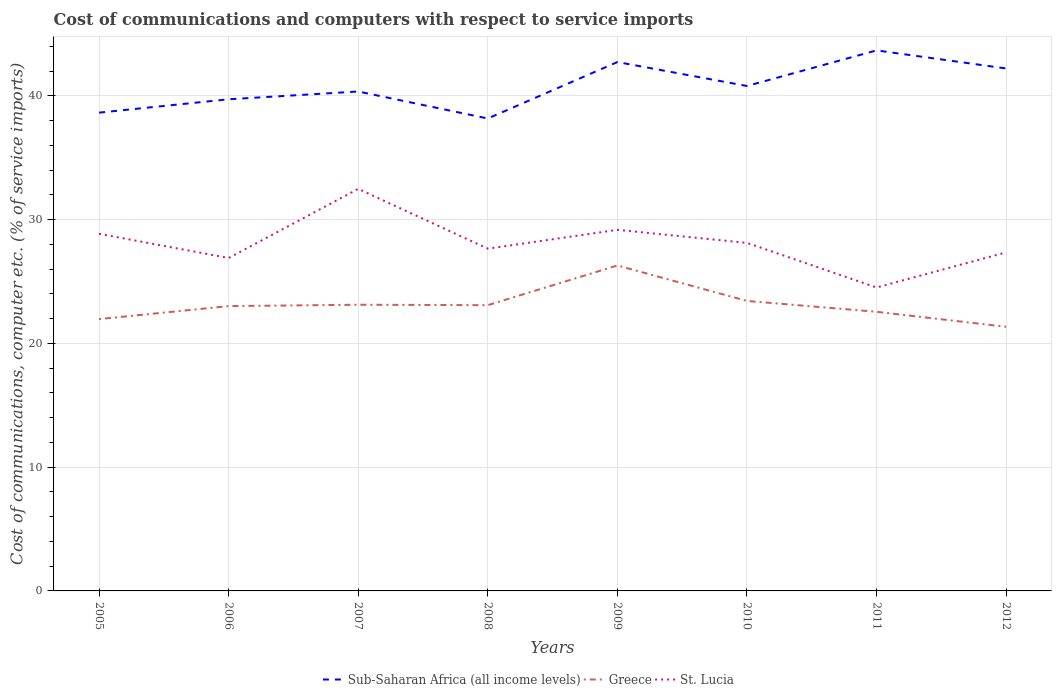Is the number of lines equal to the number of legend labels?
Ensure brevity in your answer.  Yes. Across all years, what is the maximum cost of communications and computers in Sub-Saharan Africa (all income levels)?
Your answer should be very brief. 38.18. In which year was the cost of communications and computers in Greece maximum?
Keep it short and to the point. 2012. What is the total cost of communications and computers in Greece in the graph?
Keep it short and to the point. 1.67. What is the difference between the highest and the second highest cost of communications and computers in St. Lucia?
Offer a very short reply. 7.97. What is the difference between the highest and the lowest cost of communications and computers in Greece?
Make the answer very short. 3. What is the difference between two consecutive major ticks on the Y-axis?
Your answer should be very brief. 10. How are the legend labels stacked?
Your answer should be very brief. Horizontal. What is the title of the graph?
Offer a very short reply. Cost of communications and computers with respect to service imports. Does "Lithuania" appear as one of the legend labels in the graph?
Your answer should be compact. No. What is the label or title of the Y-axis?
Keep it short and to the point. Cost of communications, computer etc. (% of service imports). What is the Cost of communications, computer etc. (% of service imports) in Sub-Saharan Africa (all income levels) in 2005?
Make the answer very short. 38.65. What is the Cost of communications, computer etc. (% of service imports) in Greece in 2005?
Ensure brevity in your answer.  21.97. What is the Cost of communications, computer etc. (% of service imports) of St. Lucia in 2005?
Your answer should be compact. 28.86. What is the Cost of communications, computer etc. (% of service imports) in Sub-Saharan Africa (all income levels) in 2006?
Provide a succinct answer. 39.73. What is the Cost of communications, computer etc. (% of service imports) in Greece in 2006?
Offer a terse response. 23.02. What is the Cost of communications, computer etc. (% of service imports) of St. Lucia in 2006?
Keep it short and to the point. 26.91. What is the Cost of communications, computer etc. (% of service imports) in Sub-Saharan Africa (all income levels) in 2007?
Make the answer very short. 40.36. What is the Cost of communications, computer etc. (% of service imports) in Greece in 2007?
Provide a short and direct response. 23.13. What is the Cost of communications, computer etc. (% of service imports) of St. Lucia in 2007?
Your answer should be compact. 32.49. What is the Cost of communications, computer etc. (% of service imports) of Sub-Saharan Africa (all income levels) in 2008?
Your answer should be compact. 38.18. What is the Cost of communications, computer etc. (% of service imports) in Greece in 2008?
Provide a short and direct response. 23.09. What is the Cost of communications, computer etc. (% of service imports) in St. Lucia in 2008?
Ensure brevity in your answer.  27.66. What is the Cost of communications, computer etc. (% of service imports) of Sub-Saharan Africa (all income levels) in 2009?
Ensure brevity in your answer.  42.74. What is the Cost of communications, computer etc. (% of service imports) of Greece in 2009?
Your response must be concise. 26.3. What is the Cost of communications, computer etc. (% of service imports) in St. Lucia in 2009?
Offer a very short reply. 29.18. What is the Cost of communications, computer etc. (% of service imports) of Sub-Saharan Africa (all income levels) in 2010?
Your answer should be compact. 40.81. What is the Cost of communications, computer etc. (% of service imports) of Greece in 2010?
Offer a terse response. 23.44. What is the Cost of communications, computer etc. (% of service imports) in St. Lucia in 2010?
Your answer should be compact. 28.13. What is the Cost of communications, computer etc. (% of service imports) of Sub-Saharan Africa (all income levels) in 2011?
Offer a terse response. 43.68. What is the Cost of communications, computer etc. (% of service imports) in Greece in 2011?
Offer a very short reply. 22.56. What is the Cost of communications, computer etc. (% of service imports) in St. Lucia in 2011?
Ensure brevity in your answer.  24.52. What is the Cost of communications, computer etc. (% of service imports) of Sub-Saharan Africa (all income levels) in 2012?
Make the answer very short. 42.22. What is the Cost of communications, computer etc. (% of service imports) in Greece in 2012?
Keep it short and to the point. 21.35. What is the Cost of communications, computer etc. (% of service imports) of St. Lucia in 2012?
Keep it short and to the point. 27.36. Across all years, what is the maximum Cost of communications, computer etc. (% of service imports) of Sub-Saharan Africa (all income levels)?
Your response must be concise. 43.68. Across all years, what is the maximum Cost of communications, computer etc. (% of service imports) in Greece?
Offer a terse response. 26.3. Across all years, what is the maximum Cost of communications, computer etc. (% of service imports) in St. Lucia?
Make the answer very short. 32.49. Across all years, what is the minimum Cost of communications, computer etc. (% of service imports) in Sub-Saharan Africa (all income levels)?
Make the answer very short. 38.18. Across all years, what is the minimum Cost of communications, computer etc. (% of service imports) of Greece?
Make the answer very short. 21.35. Across all years, what is the minimum Cost of communications, computer etc. (% of service imports) in St. Lucia?
Offer a terse response. 24.52. What is the total Cost of communications, computer etc. (% of service imports) in Sub-Saharan Africa (all income levels) in the graph?
Provide a succinct answer. 326.39. What is the total Cost of communications, computer etc. (% of service imports) in Greece in the graph?
Your answer should be compact. 184.85. What is the total Cost of communications, computer etc. (% of service imports) of St. Lucia in the graph?
Offer a terse response. 225.11. What is the difference between the Cost of communications, computer etc. (% of service imports) of Sub-Saharan Africa (all income levels) in 2005 and that in 2006?
Your answer should be compact. -1.08. What is the difference between the Cost of communications, computer etc. (% of service imports) in Greece in 2005 and that in 2006?
Provide a succinct answer. -1.05. What is the difference between the Cost of communications, computer etc. (% of service imports) in St. Lucia in 2005 and that in 2006?
Your response must be concise. 1.96. What is the difference between the Cost of communications, computer etc. (% of service imports) in Sub-Saharan Africa (all income levels) in 2005 and that in 2007?
Offer a terse response. -1.71. What is the difference between the Cost of communications, computer etc. (% of service imports) of Greece in 2005 and that in 2007?
Offer a very short reply. -1.16. What is the difference between the Cost of communications, computer etc. (% of service imports) in St. Lucia in 2005 and that in 2007?
Give a very brief answer. -3.63. What is the difference between the Cost of communications, computer etc. (% of service imports) of Sub-Saharan Africa (all income levels) in 2005 and that in 2008?
Keep it short and to the point. 0.47. What is the difference between the Cost of communications, computer etc. (% of service imports) in Greece in 2005 and that in 2008?
Keep it short and to the point. -1.13. What is the difference between the Cost of communications, computer etc. (% of service imports) in St. Lucia in 2005 and that in 2008?
Provide a short and direct response. 1.21. What is the difference between the Cost of communications, computer etc. (% of service imports) in Sub-Saharan Africa (all income levels) in 2005 and that in 2009?
Your answer should be very brief. -4.09. What is the difference between the Cost of communications, computer etc. (% of service imports) of Greece in 2005 and that in 2009?
Offer a very short reply. -4.33. What is the difference between the Cost of communications, computer etc. (% of service imports) of St. Lucia in 2005 and that in 2009?
Keep it short and to the point. -0.32. What is the difference between the Cost of communications, computer etc. (% of service imports) in Sub-Saharan Africa (all income levels) in 2005 and that in 2010?
Your answer should be very brief. -2.15. What is the difference between the Cost of communications, computer etc. (% of service imports) in Greece in 2005 and that in 2010?
Your answer should be compact. -1.47. What is the difference between the Cost of communications, computer etc. (% of service imports) of St. Lucia in 2005 and that in 2010?
Offer a very short reply. 0.74. What is the difference between the Cost of communications, computer etc. (% of service imports) of Sub-Saharan Africa (all income levels) in 2005 and that in 2011?
Ensure brevity in your answer.  -5.03. What is the difference between the Cost of communications, computer etc. (% of service imports) of Greece in 2005 and that in 2011?
Your response must be concise. -0.59. What is the difference between the Cost of communications, computer etc. (% of service imports) in St. Lucia in 2005 and that in 2011?
Make the answer very short. 4.34. What is the difference between the Cost of communications, computer etc. (% of service imports) in Sub-Saharan Africa (all income levels) in 2005 and that in 2012?
Make the answer very short. -3.57. What is the difference between the Cost of communications, computer etc. (% of service imports) of Greece in 2005 and that in 2012?
Provide a short and direct response. 0.62. What is the difference between the Cost of communications, computer etc. (% of service imports) of St. Lucia in 2005 and that in 2012?
Provide a succinct answer. 1.5. What is the difference between the Cost of communications, computer etc. (% of service imports) in Sub-Saharan Africa (all income levels) in 2006 and that in 2007?
Give a very brief answer. -0.63. What is the difference between the Cost of communications, computer etc. (% of service imports) of Greece in 2006 and that in 2007?
Provide a short and direct response. -0.11. What is the difference between the Cost of communications, computer etc. (% of service imports) of St. Lucia in 2006 and that in 2007?
Your answer should be compact. -5.59. What is the difference between the Cost of communications, computer etc. (% of service imports) in Sub-Saharan Africa (all income levels) in 2006 and that in 2008?
Keep it short and to the point. 1.55. What is the difference between the Cost of communications, computer etc. (% of service imports) of Greece in 2006 and that in 2008?
Your response must be concise. -0.08. What is the difference between the Cost of communications, computer etc. (% of service imports) in St. Lucia in 2006 and that in 2008?
Provide a succinct answer. -0.75. What is the difference between the Cost of communications, computer etc. (% of service imports) in Sub-Saharan Africa (all income levels) in 2006 and that in 2009?
Offer a terse response. -3.01. What is the difference between the Cost of communications, computer etc. (% of service imports) of Greece in 2006 and that in 2009?
Give a very brief answer. -3.28. What is the difference between the Cost of communications, computer etc. (% of service imports) in St. Lucia in 2006 and that in 2009?
Make the answer very short. -2.28. What is the difference between the Cost of communications, computer etc. (% of service imports) in Sub-Saharan Africa (all income levels) in 2006 and that in 2010?
Your answer should be compact. -1.07. What is the difference between the Cost of communications, computer etc. (% of service imports) in Greece in 2006 and that in 2010?
Provide a succinct answer. -0.42. What is the difference between the Cost of communications, computer etc. (% of service imports) in St. Lucia in 2006 and that in 2010?
Offer a terse response. -1.22. What is the difference between the Cost of communications, computer etc. (% of service imports) in Sub-Saharan Africa (all income levels) in 2006 and that in 2011?
Your response must be concise. -3.95. What is the difference between the Cost of communications, computer etc. (% of service imports) of Greece in 2006 and that in 2011?
Ensure brevity in your answer.  0.46. What is the difference between the Cost of communications, computer etc. (% of service imports) in St. Lucia in 2006 and that in 2011?
Make the answer very short. 2.38. What is the difference between the Cost of communications, computer etc. (% of service imports) in Sub-Saharan Africa (all income levels) in 2006 and that in 2012?
Provide a succinct answer. -2.49. What is the difference between the Cost of communications, computer etc. (% of service imports) of Greece in 2006 and that in 2012?
Your response must be concise. 1.67. What is the difference between the Cost of communications, computer etc. (% of service imports) of St. Lucia in 2006 and that in 2012?
Your response must be concise. -0.45. What is the difference between the Cost of communications, computer etc. (% of service imports) of Sub-Saharan Africa (all income levels) in 2007 and that in 2008?
Give a very brief answer. 2.18. What is the difference between the Cost of communications, computer etc. (% of service imports) of Greece in 2007 and that in 2008?
Your response must be concise. 0.04. What is the difference between the Cost of communications, computer etc. (% of service imports) of St. Lucia in 2007 and that in 2008?
Offer a terse response. 4.83. What is the difference between the Cost of communications, computer etc. (% of service imports) of Sub-Saharan Africa (all income levels) in 2007 and that in 2009?
Offer a terse response. -2.38. What is the difference between the Cost of communications, computer etc. (% of service imports) of Greece in 2007 and that in 2009?
Offer a very short reply. -3.17. What is the difference between the Cost of communications, computer etc. (% of service imports) of St. Lucia in 2007 and that in 2009?
Offer a terse response. 3.31. What is the difference between the Cost of communications, computer etc. (% of service imports) of Sub-Saharan Africa (all income levels) in 2007 and that in 2010?
Offer a terse response. -0.45. What is the difference between the Cost of communications, computer etc. (% of service imports) of Greece in 2007 and that in 2010?
Provide a short and direct response. -0.31. What is the difference between the Cost of communications, computer etc. (% of service imports) of St. Lucia in 2007 and that in 2010?
Make the answer very short. 4.36. What is the difference between the Cost of communications, computer etc. (% of service imports) in Sub-Saharan Africa (all income levels) in 2007 and that in 2011?
Your answer should be very brief. -3.32. What is the difference between the Cost of communications, computer etc. (% of service imports) in Greece in 2007 and that in 2011?
Your answer should be compact. 0.57. What is the difference between the Cost of communications, computer etc. (% of service imports) of St. Lucia in 2007 and that in 2011?
Provide a short and direct response. 7.97. What is the difference between the Cost of communications, computer etc. (% of service imports) of Sub-Saharan Africa (all income levels) in 2007 and that in 2012?
Keep it short and to the point. -1.86. What is the difference between the Cost of communications, computer etc. (% of service imports) of Greece in 2007 and that in 2012?
Your answer should be compact. 1.78. What is the difference between the Cost of communications, computer etc. (% of service imports) in St. Lucia in 2007 and that in 2012?
Make the answer very short. 5.13. What is the difference between the Cost of communications, computer etc. (% of service imports) in Sub-Saharan Africa (all income levels) in 2008 and that in 2009?
Offer a very short reply. -4.56. What is the difference between the Cost of communications, computer etc. (% of service imports) of Greece in 2008 and that in 2009?
Make the answer very short. -3.21. What is the difference between the Cost of communications, computer etc. (% of service imports) in St. Lucia in 2008 and that in 2009?
Your response must be concise. -1.52. What is the difference between the Cost of communications, computer etc. (% of service imports) of Sub-Saharan Africa (all income levels) in 2008 and that in 2010?
Offer a very short reply. -2.63. What is the difference between the Cost of communications, computer etc. (% of service imports) in Greece in 2008 and that in 2010?
Your answer should be compact. -0.34. What is the difference between the Cost of communications, computer etc. (% of service imports) of St. Lucia in 2008 and that in 2010?
Give a very brief answer. -0.47. What is the difference between the Cost of communications, computer etc. (% of service imports) in Sub-Saharan Africa (all income levels) in 2008 and that in 2011?
Ensure brevity in your answer.  -5.5. What is the difference between the Cost of communications, computer etc. (% of service imports) of Greece in 2008 and that in 2011?
Make the answer very short. 0.53. What is the difference between the Cost of communications, computer etc. (% of service imports) of St. Lucia in 2008 and that in 2011?
Your response must be concise. 3.14. What is the difference between the Cost of communications, computer etc. (% of service imports) of Sub-Saharan Africa (all income levels) in 2008 and that in 2012?
Offer a very short reply. -4.04. What is the difference between the Cost of communications, computer etc. (% of service imports) in Greece in 2008 and that in 2012?
Provide a succinct answer. 1.75. What is the difference between the Cost of communications, computer etc. (% of service imports) in St. Lucia in 2008 and that in 2012?
Your answer should be compact. 0.3. What is the difference between the Cost of communications, computer etc. (% of service imports) in Sub-Saharan Africa (all income levels) in 2009 and that in 2010?
Provide a short and direct response. 1.93. What is the difference between the Cost of communications, computer etc. (% of service imports) in Greece in 2009 and that in 2010?
Make the answer very short. 2.87. What is the difference between the Cost of communications, computer etc. (% of service imports) in St. Lucia in 2009 and that in 2010?
Give a very brief answer. 1.06. What is the difference between the Cost of communications, computer etc. (% of service imports) of Sub-Saharan Africa (all income levels) in 2009 and that in 2011?
Offer a terse response. -0.94. What is the difference between the Cost of communications, computer etc. (% of service imports) of Greece in 2009 and that in 2011?
Offer a terse response. 3.74. What is the difference between the Cost of communications, computer etc. (% of service imports) in St. Lucia in 2009 and that in 2011?
Keep it short and to the point. 4.66. What is the difference between the Cost of communications, computer etc. (% of service imports) of Sub-Saharan Africa (all income levels) in 2009 and that in 2012?
Make the answer very short. 0.52. What is the difference between the Cost of communications, computer etc. (% of service imports) in Greece in 2009 and that in 2012?
Provide a succinct answer. 4.96. What is the difference between the Cost of communications, computer etc. (% of service imports) of St. Lucia in 2009 and that in 2012?
Offer a terse response. 1.82. What is the difference between the Cost of communications, computer etc. (% of service imports) of Sub-Saharan Africa (all income levels) in 2010 and that in 2011?
Give a very brief answer. -2.88. What is the difference between the Cost of communications, computer etc. (% of service imports) in Greece in 2010 and that in 2011?
Keep it short and to the point. 0.88. What is the difference between the Cost of communications, computer etc. (% of service imports) of St. Lucia in 2010 and that in 2011?
Ensure brevity in your answer.  3.6. What is the difference between the Cost of communications, computer etc. (% of service imports) of Sub-Saharan Africa (all income levels) in 2010 and that in 2012?
Provide a short and direct response. -1.42. What is the difference between the Cost of communications, computer etc. (% of service imports) in Greece in 2010 and that in 2012?
Provide a short and direct response. 2.09. What is the difference between the Cost of communications, computer etc. (% of service imports) in St. Lucia in 2010 and that in 2012?
Ensure brevity in your answer.  0.77. What is the difference between the Cost of communications, computer etc. (% of service imports) of Sub-Saharan Africa (all income levels) in 2011 and that in 2012?
Make the answer very short. 1.46. What is the difference between the Cost of communications, computer etc. (% of service imports) of Greece in 2011 and that in 2012?
Ensure brevity in your answer.  1.21. What is the difference between the Cost of communications, computer etc. (% of service imports) in St. Lucia in 2011 and that in 2012?
Your response must be concise. -2.84. What is the difference between the Cost of communications, computer etc. (% of service imports) of Sub-Saharan Africa (all income levels) in 2005 and the Cost of communications, computer etc. (% of service imports) of Greece in 2006?
Your answer should be compact. 15.64. What is the difference between the Cost of communications, computer etc. (% of service imports) in Sub-Saharan Africa (all income levels) in 2005 and the Cost of communications, computer etc. (% of service imports) in St. Lucia in 2006?
Provide a succinct answer. 11.75. What is the difference between the Cost of communications, computer etc. (% of service imports) of Greece in 2005 and the Cost of communications, computer etc. (% of service imports) of St. Lucia in 2006?
Keep it short and to the point. -4.94. What is the difference between the Cost of communications, computer etc. (% of service imports) in Sub-Saharan Africa (all income levels) in 2005 and the Cost of communications, computer etc. (% of service imports) in Greece in 2007?
Your response must be concise. 15.52. What is the difference between the Cost of communications, computer etc. (% of service imports) in Sub-Saharan Africa (all income levels) in 2005 and the Cost of communications, computer etc. (% of service imports) in St. Lucia in 2007?
Your answer should be compact. 6.16. What is the difference between the Cost of communications, computer etc. (% of service imports) of Greece in 2005 and the Cost of communications, computer etc. (% of service imports) of St. Lucia in 2007?
Offer a terse response. -10.52. What is the difference between the Cost of communications, computer etc. (% of service imports) of Sub-Saharan Africa (all income levels) in 2005 and the Cost of communications, computer etc. (% of service imports) of Greece in 2008?
Offer a terse response. 15.56. What is the difference between the Cost of communications, computer etc. (% of service imports) of Sub-Saharan Africa (all income levels) in 2005 and the Cost of communications, computer etc. (% of service imports) of St. Lucia in 2008?
Make the answer very short. 11. What is the difference between the Cost of communications, computer etc. (% of service imports) of Greece in 2005 and the Cost of communications, computer etc. (% of service imports) of St. Lucia in 2008?
Your answer should be very brief. -5.69. What is the difference between the Cost of communications, computer etc. (% of service imports) of Sub-Saharan Africa (all income levels) in 2005 and the Cost of communications, computer etc. (% of service imports) of Greece in 2009?
Offer a terse response. 12.35. What is the difference between the Cost of communications, computer etc. (% of service imports) in Sub-Saharan Africa (all income levels) in 2005 and the Cost of communications, computer etc. (% of service imports) in St. Lucia in 2009?
Offer a terse response. 9.47. What is the difference between the Cost of communications, computer etc. (% of service imports) of Greece in 2005 and the Cost of communications, computer etc. (% of service imports) of St. Lucia in 2009?
Provide a short and direct response. -7.21. What is the difference between the Cost of communications, computer etc. (% of service imports) in Sub-Saharan Africa (all income levels) in 2005 and the Cost of communications, computer etc. (% of service imports) in Greece in 2010?
Provide a succinct answer. 15.22. What is the difference between the Cost of communications, computer etc. (% of service imports) in Sub-Saharan Africa (all income levels) in 2005 and the Cost of communications, computer etc. (% of service imports) in St. Lucia in 2010?
Ensure brevity in your answer.  10.53. What is the difference between the Cost of communications, computer etc. (% of service imports) of Greece in 2005 and the Cost of communications, computer etc. (% of service imports) of St. Lucia in 2010?
Provide a succinct answer. -6.16. What is the difference between the Cost of communications, computer etc. (% of service imports) in Sub-Saharan Africa (all income levels) in 2005 and the Cost of communications, computer etc. (% of service imports) in Greece in 2011?
Provide a succinct answer. 16.1. What is the difference between the Cost of communications, computer etc. (% of service imports) of Sub-Saharan Africa (all income levels) in 2005 and the Cost of communications, computer etc. (% of service imports) of St. Lucia in 2011?
Keep it short and to the point. 14.13. What is the difference between the Cost of communications, computer etc. (% of service imports) of Greece in 2005 and the Cost of communications, computer etc. (% of service imports) of St. Lucia in 2011?
Your answer should be very brief. -2.55. What is the difference between the Cost of communications, computer etc. (% of service imports) in Sub-Saharan Africa (all income levels) in 2005 and the Cost of communications, computer etc. (% of service imports) in Greece in 2012?
Ensure brevity in your answer.  17.31. What is the difference between the Cost of communications, computer etc. (% of service imports) of Sub-Saharan Africa (all income levels) in 2005 and the Cost of communications, computer etc. (% of service imports) of St. Lucia in 2012?
Make the answer very short. 11.29. What is the difference between the Cost of communications, computer etc. (% of service imports) in Greece in 2005 and the Cost of communications, computer etc. (% of service imports) in St. Lucia in 2012?
Your answer should be compact. -5.39. What is the difference between the Cost of communications, computer etc. (% of service imports) in Sub-Saharan Africa (all income levels) in 2006 and the Cost of communications, computer etc. (% of service imports) in Greece in 2007?
Make the answer very short. 16.61. What is the difference between the Cost of communications, computer etc. (% of service imports) in Sub-Saharan Africa (all income levels) in 2006 and the Cost of communications, computer etc. (% of service imports) in St. Lucia in 2007?
Provide a succinct answer. 7.24. What is the difference between the Cost of communications, computer etc. (% of service imports) of Greece in 2006 and the Cost of communications, computer etc. (% of service imports) of St. Lucia in 2007?
Offer a terse response. -9.47. What is the difference between the Cost of communications, computer etc. (% of service imports) of Sub-Saharan Africa (all income levels) in 2006 and the Cost of communications, computer etc. (% of service imports) of Greece in 2008?
Offer a terse response. 16.64. What is the difference between the Cost of communications, computer etc. (% of service imports) in Sub-Saharan Africa (all income levels) in 2006 and the Cost of communications, computer etc. (% of service imports) in St. Lucia in 2008?
Ensure brevity in your answer.  12.08. What is the difference between the Cost of communications, computer etc. (% of service imports) in Greece in 2006 and the Cost of communications, computer etc. (% of service imports) in St. Lucia in 2008?
Make the answer very short. -4.64. What is the difference between the Cost of communications, computer etc. (% of service imports) of Sub-Saharan Africa (all income levels) in 2006 and the Cost of communications, computer etc. (% of service imports) of Greece in 2009?
Your answer should be very brief. 13.43. What is the difference between the Cost of communications, computer etc. (% of service imports) in Sub-Saharan Africa (all income levels) in 2006 and the Cost of communications, computer etc. (% of service imports) in St. Lucia in 2009?
Make the answer very short. 10.55. What is the difference between the Cost of communications, computer etc. (% of service imports) in Greece in 2006 and the Cost of communications, computer etc. (% of service imports) in St. Lucia in 2009?
Your response must be concise. -6.16. What is the difference between the Cost of communications, computer etc. (% of service imports) in Sub-Saharan Africa (all income levels) in 2006 and the Cost of communications, computer etc. (% of service imports) in Greece in 2010?
Offer a terse response. 16.3. What is the difference between the Cost of communications, computer etc. (% of service imports) of Sub-Saharan Africa (all income levels) in 2006 and the Cost of communications, computer etc. (% of service imports) of St. Lucia in 2010?
Ensure brevity in your answer.  11.61. What is the difference between the Cost of communications, computer etc. (% of service imports) of Greece in 2006 and the Cost of communications, computer etc. (% of service imports) of St. Lucia in 2010?
Your answer should be compact. -5.11. What is the difference between the Cost of communications, computer etc. (% of service imports) of Sub-Saharan Africa (all income levels) in 2006 and the Cost of communications, computer etc. (% of service imports) of Greece in 2011?
Your answer should be very brief. 17.18. What is the difference between the Cost of communications, computer etc. (% of service imports) of Sub-Saharan Africa (all income levels) in 2006 and the Cost of communications, computer etc. (% of service imports) of St. Lucia in 2011?
Make the answer very short. 15.21. What is the difference between the Cost of communications, computer etc. (% of service imports) of Greece in 2006 and the Cost of communications, computer etc. (% of service imports) of St. Lucia in 2011?
Give a very brief answer. -1.5. What is the difference between the Cost of communications, computer etc. (% of service imports) in Sub-Saharan Africa (all income levels) in 2006 and the Cost of communications, computer etc. (% of service imports) in Greece in 2012?
Offer a very short reply. 18.39. What is the difference between the Cost of communications, computer etc. (% of service imports) in Sub-Saharan Africa (all income levels) in 2006 and the Cost of communications, computer etc. (% of service imports) in St. Lucia in 2012?
Offer a very short reply. 12.37. What is the difference between the Cost of communications, computer etc. (% of service imports) of Greece in 2006 and the Cost of communications, computer etc. (% of service imports) of St. Lucia in 2012?
Provide a short and direct response. -4.34. What is the difference between the Cost of communications, computer etc. (% of service imports) of Sub-Saharan Africa (all income levels) in 2007 and the Cost of communications, computer etc. (% of service imports) of Greece in 2008?
Ensure brevity in your answer.  17.27. What is the difference between the Cost of communications, computer etc. (% of service imports) of Sub-Saharan Africa (all income levels) in 2007 and the Cost of communications, computer etc. (% of service imports) of St. Lucia in 2008?
Offer a very short reply. 12.7. What is the difference between the Cost of communications, computer etc. (% of service imports) in Greece in 2007 and the Cost of communications, computer etc. (% of service imports) in St. Lucia in 2008?
Offer a terse response. -4.53. What is the difference between the Cost of communications, computer etc. (% of service imports) of Sub-Saharan Africa (all income levels) in 2007 and the Cost of communications, computer etc. (% of service imports) of Greece in 2009?
Your answer should be very brief. 14.06. What is the difference between the Cost of communications, computer etc. (% of service imports) of Sub-Saharan Africa (all income levels) in 2007 and the Cost of communications, computer etc. (% of service imports) of St. Lucia in 2009?
Make the answer very short. 11.18. What is the difference between the Cost of communications, computer etc. (% of service imports) in Greece in 2007 and the Cost of communications, computer etc. (% of service imports) in St. Lucia in 2009?
Your answer should be very brief. -6.05. What is the difference between the Cost of communications, computer etc. (% of service imports) of Sub-Saharan Africa (all income levels) in 2007 and the Cost of communications, computer etc. (% of service imports) of Greece in 2010?
Give a very brief answer. 16.93. What is the difference between the Cost of communications, computer etc. (% of service imports) of Sub-Saharan Africa (all income levels) in 2007 and the Cost of communications, computer etc. (% of service imports) of St. Lucia in 2010?
Offer a terse response. 12.24. What is the difference between the Cost of communications, computer etc. (% of service imports) in Greece in 2007 and the Cost of communications, computer etc. (% of service imports) in St. Lucia in 2010?
Ensure brevity in your answer.  -5. What is the difference between the Cost of communications, computer etc. (% of service imports) of Sub-Saharan Africa (all income levels) in 2007 and the Cost of communications, computer etc. (% of service imports) of Greece in 2011?
Your answer should be very brief. 17.8. What is the difference between the Cost of communications, computer etc. (% of service imports) of Sub-Saharan Africa (all income levels) in 2007 and the Cost of communications, computer etc. (% of service imports) of St. Lucia in 2011?
Make the answer very short. 15.84. What is the difference between the Cost of communications, computer etc. (% of service imports) in Greece in 2007 and the Cost of communications, computer etc. (% of service imports) in St. Lucia in 2011?
Provide a short and direct response. -1.39. What is the difference between the Cost of communications, computer etc. (% of service imports) in Sub-Saharan Africa (all income levels) in 2007 and the Cost of communications, computer etc. (% of service imports) in Greece in 2012?
Give a very brief answer. 19.02. What is the difference between the Cost of communications, computer etc. (% of service imports) of Sub-Saharan Africa (all income levels) in 2007 and the Cost of communications, computer etc. (% of service imports) of St. Lucia in 2012?
Keep it short and to the point. 13. What is the difference between the Cost of communications, computer etc. (% of service imports) of Greece in 2007 and the Cost of communications, computer etc. (% of service imports) of St. Lucia in 2012?
Keep it short and to the point. -4.23. What is the difference between the Cost of communications, computer etc. (% of service imports) in Sub-Saharan Africa (all income levels) in 2008 and the Cost of communications, computer etc. (% of service imports) in Greece in 2009?
Ensure brevity in your answer.  11.88. What is the difference between the Cost of communications, computer etc. (% of service imports) of Sub-Saharan Africa (all income levels) in 2008 and the Cost of communications, computer etc. (% of service imports) of St. Lucia in 2009?
Make the answer very short. 9. What is the difference between the Cost of communications, computer etc. (% of service imports) in Greece in 2008 and the Cost of communications, computer etc. (% of service imports) in St. Lucia in 2009?
Make the answer very short. -6.09. What is the difference between the Cost of communications, computer etc. (% of service imports) in Sub-Saharan Africa (all income levels) in 2008 and the Cost of communications, computer etc. (% of service imports) in Greece in 2010?
Offer a terse response. 14.75. What is the difference between the Cost of communications, computer etc. (% of service imports) in Sub-Saharan Africa (all income levels) in 2008 and the Cost of communications, computer etc. (% of service imports) in St. Lucia in 2010?
Ensure brevity in your answer.  10.05. What is the difference between the Cost of communications, computer etc. (% of service imports) of Greece in 2008 and the Cost of communications, computer etc. (% of service imports) of St. Lucia in 2010?
Give a very brief answer. -5.03. What is the difference between the Cost of communications, computer etc. (% of service imports) in Sub-Saharan Africa (all income levels) in 2008 and the Cost of communications, computer etc. (% of service imports) in Greece in 2011?
Ensure brevity in your answer.  15.62. What is the difference between the Cost of communications, computer etc. (% of service imports) in Sub-Saharan Africa (all income levels) in 2008 and the Cost of communications, computer etc. (% of service imports) in St. Lucia in 2011?
Your answer should be very brief. 13.66. What is the difference between the Cost of communications, computer etc. (% of service imports) of Greece in 2008 and the Cost of communications, computer etc. (% of service imports) of St. Lucia in 2011?
Offer a very short reply. -1.43. What is the difference between the Cost of communications, computer etc. (% of service imports) in Sub-Saharan Africa (all income levels) in 2008 and the Cost of communications, computer etc. (% of service imports) in Greece in 2012?
Your response must be concise. 16.83. What is the difference between the Cost of communications, computer etc. (% of service imports) of Sub-Saharan Africa (all income levels) in 2008 and the Cost of communications, computer etc. (% of service imports) of St. Lucia in 2012?
Make the answer very short. 10.82. What is the difference between the Cost of communications, computer etc. (% of service imports) of Greece in 2008 and the Cost of communications, computer etc. (% of service imports) of St. Lucia in 2012?
Ensure brevity in your answer.  -4.27. What is the difference between the Cost of communications, computer etc. (% of service imports) in Sub-Saharan Africa (all income levels) in 2009 and the Cost of communications, computer etc. (% of service imports) in Greece in 2010?
Your response must be concise. 19.31. What is the difference between the Cost of communications, computer etc. (% of service imports) in Sub-Saharan Africa (all income levels) in 2009 and the Cost of communications, computer etc. (% of service imports) in St. Lucia in 2010?
Give a very brief answer. 14.62. What is the difference between the Cost of communications, computer etc. (% of service imports) in Greece in 2009 and the Cost of communications, computer etc. (% of service imports) in St. Lucia in 2010?
Keep it short and to the point. -1.82. What is the difference between the Cost of communications, computer etc. (% of service imports) of Sub-Saharan Africa (all income levels) in 2009 and the Cost of communications, computer etc. (% of service imports) of Greece in 2011?
Your answer should be very brief. 20.18. What is the difference between the Cost of communications, computer etc. (% of service imports) in Sub-Saharan Africa (all income levels) in 2009 and the Cost of communications, computer etc. (% of service imports) in St. Lucia in 2011?
Offer a very short reply. 18.22. What is the difference between the Cost of communications, computer etc. (% of service imports) of Greece in 2009 and the Cost of communications, computer etc. (% of service imports) of St. Lucia in 2011?
Provide a succinct answer. 1.78. What is the difference between the Cost of communications, computer etc. (% of service imports) in Sub-Saharan Africa (all income levels) in 2009 and the Cost of communications, computer etc. (% of service imports) in Greece in 2012?
Ensure brevity in your answer.  21.39. What is the difference between the Cost of communications, computer etc. (% of service imports) in Sub-Saharan Africa (all income levels) in 2009 and the Cost of communications, computer etc. (% of service imports) in St. Lucia in 2012?
Make the answer very short. 15.38. What is the difference between the Cost of communications, computer etc. (% of service imports) in Greece in 2009 and the Cost of communications, computer etc. (% of service imports) in St. Lucia in 2012?
Your answer should be very brief. -1.06. What is the difference between the Cost of communications, computer etc. (% of service imports) of Sub-Saharan Africa (all income levels) in 2010 and the Cost of communications, computer etc. (% of service imports) of Greece in 2011?
Provide a short and direct response. 18.25. What is the difference between the Cost of communications, computer etc. (% of service imports) in Sub-Saharan Africa (all income levels) in 2010 and the Cost of communications, computer etc. (% of service imports) in St. Lucia in 2011?
Offer a terse response. 16.29. What is the difference between the Cost of communications, computer etc. (% of service imports) of Greece in 2010 and the Cost of communications, computer etc. (% of service imports) of St. Lucia in 2011?
Ensure brevity in your answer.  -1.09. What is the difference between the Cost of communications, computer etc. (% of service imports) of Sub-Saharan Africa (all income levels) in 2010 and the Cost of communications, computer etc. (% of service imports) of Greece in 2012?
Your answer should be very brief. 19.46. What is the difference between the Cost of communications, computer etc. (% of service imports) of Sub-Saharan Africa (all income levels) in 2010 and the Cost of communications, computer etc. (% of service imports) of St. Lucia in 2012?
Make the answer very short. 13.45. What is the difference between the Cost of communications, computer etc. (% of service imports) of Greece in 2010 and the Cost of communications, computer etc. (% of service imports) of St. Lucia in 2012?
Give a very brief answer. -3.93. What is the difference between the Cost of communications, computer etc. (% of service imports) in Sub-Saharan Africa (all income levels) in 2011 and the Cost of communications, computer etc. (% of service imports) in Greece in 2012?
Make the answer very short. 22.34. What is the difference between the Cost of communications, computer etc. (% of service imports) in Sub-Saharan Africa (all income levels) in 2011 and the Cost of communications, computer etc. (% of service imports) in St. Lucia in 2012?
Your answer should be compact. 16.32. What is the difference between the Cost of communications, computer etc. (% of service imports) in Greece in 2011 and the Cost of communications, computer etc. (% of service imports) in St. Lucia in 2012?
Ensure brevity in your answer.  -4.8. What is the average Cost of communications, computer etc. (% of service imports) in Sub-Saharan Africa (all income levels) per year?
Make the answer very short. 40.8. What is the average Cost of communications, computer etc. (% of service imports) in Greece per year?
Provide a succinct answer. 23.11. What is the average Cost of communications, computer etc. (% of service imports) of St. Lucia per year?
Offer a terse response. 28.14. In the year 2005, what is the difference between the Cost of communications, computer etc. (% of service imports) of Sub-Saharan Africa (all income levels) and Cost of communications, computer etc. (% of service imports) of Greece?
Your answer should be compact. 16.69. In the year 2005, what is the difference between the Cost of communications, computer etc. (% of service imports) of Sub-Saharan Africa (all income levels) and Cost of communications, computer etc. (% of service imports) of St. Lucia?
Give a very brief answer. 9.79. In the year 2005, what is the difference between the Cost of communications, computer etc. (% of service imports) of Greece and Cost of communications, computer etc. (% of service imports) of St. Lucia?
Provide a succinct answer. -6.9. In the year 2006, what is the difference between the Cost of communications, computer etc. (% of service imports) of Sub-Saharan Africa (all income levels) and Cost of communications, computer etc. (% of service imports) of Greece?
Offer a terse response. 16.72. In the year 2006, what is the difference between the Cost of communications, computer etc. (% of service imports) in Sub-Saharan Africa (all income levels) and Cost of communications, computer etc. (% of service imports) in St. Lucia?
Keep it short and to the point. 12.83. In the year 2006, what is the difference between the Cost of communications, computer etc. (% of service imports) of Greece and Cost of communications, computer etc. (% of service imports) of St. Lucia?
Provide a short and direct response. -3.89. In the year 2007, what is the difference between the Cost of communications, computer etc. (% of service imports) of Sub-Saharan Africa (all income levels) and Cost of communications, computer etc. (% of service imports) of Greece?
Your response must be concise. 17.23. In the year 2007, what is the difference between the Cost of communications, computer etc. (% of service imports) in Sub-Saharan Africa (all income levels) and Cost of communications, computer etc. (% of service imports) in St. Lucia?
Provide a short and direct response. 7.87. In the year 2007, what is the difference between the Cost of communications, computer etc. (% of service imports) in Greece and Cost of communications, computer etc. (% of service imports) in St. Lucia?
Provide a succinct answer. -9.36. In the year 2008, what is the difference between the Cost of communications, computer etc. (% of service imports) in Sub-Saharan Africa (all income levels) and Cost of communications, computer etc. (% of service imports) in Greece?
Your answer should be compact. 15.09. In the year 2008, what is the difference between the Cost of communications, computer etc. (% of service imports) of Sub-Saharan Africa (all income levels) and Cost of communications, computer etc. (% of service imports) of St. Lucia?
Give a very brief answer. 10.52. In the year 2008, what is the difference between the Cost of communications, computer etc. (% of service imports) of Greece and Cost of communications, computer etc. (% of service imports) of St. Lucia?
Your response must be concise. -4.57. In the year 2009, what is the difference between the Cost of communications, computer etc. (% of service imports) in Sub-Saharan Africa (all income levels) and Cost of communications, computer etc. (% of service imports) in Greece?
Make the answer very short. 16.44. In the year 2009, what is the difference between the Cost of communications, computer etc. (% of service imports) in Sub-Saharan Africa (all income levels) and Cost of communications, computer etc. (% of service imports) in St. Lucia?
Provide a short and direct response. 13.56. In the year 2009, what is the difference between the Cost of communications, computer etc. (% of service imports) in Greece and Cost of communications, computer etc. (% of service imports) in St. Lucia?
Your answer should be very brief. -2.88. In the year 2010, what is the difference between the Cost of communications, computer etc. (% of service imports) of Sub-Saharan Africa (all income levels) and Cost of communications, computer etc. (% of service imports) of Greece?
Ensure brevity in your answer.  17.37. In the year 2010, what is the difference between the Cost of communications, computer etc. (% of service imports) in Sub-Saharan Africa (all income levels) and Cost of communications, computer etc. (% of service imports) in St. Lucia?
Keep it short and to the point. 12.68. In the year 2010, what is the difference between the Cost of communications, computer etc. (% of service imports) of Greece and Cost of communications, computer etc. (% of service imports) of St. Lucia?
Make the answer very short. -4.69. In the year 2011, what is the difference between the Cost of communications, computer etc. (% of service imports) in Sub-Saharan Africa (all income levels) and Cost of communications, computer etc. (% of service imports) in Greece?
Give a very brief answer. 21.13. In the year 2011, what is the difference between the Cost of communications, computer etc. (% of service imports) in Sub-Saharan Africa (all income levels) and Cost of communications, computer etc. (% of service imports) in St. Lucia?
Provide a short and direct response. 19.16. In the year 2011, what is the difference between the Cost of communications, computer etc. (% of service imports) of Greece and Cost of communications, computer etc. (% of service imports) of St. Lucia?
Provide a succinct answer. -1.96. In the year 2012, what is the difference between the Cost of communications, computer etc. (% of service imports) in Sub-Saharan Africa (all income levels) and Cost of communications, computer etc. (% of service imports) in Greece?
Give a very brief answer. 20.88. In the year 2012, what is the difference between the Cost of communications, computer etc. (% of service imports) of Sub-Saharan Africa (all income levels) and Cost of communications, computer etc. (% of service imports) of St. Lucia?
Offer a terse response. 14.86. In the year 2012, what is the difference between the Cost of communications, computer etc. (% of service imports) in Greece and Cost of communications, computer etc. (% of service imports) in St. Lucia?
Provide a succinct answer. -6.01. What is the ratio of the Cost of communications, computer etc. (% of service imports) of Sub-Saharan Africa (all income levels) in 2005 to that in 2006?
Offer a very short reply. 0.97. What is the ratio of the Cost of communications, computer etc. (% of service imports) of Greece in 2005 to that in 2006?
Offer a terse response. 0.95. What is the ratio of the Cost of communications, computer etc. (% of service imports) of St. Lucia in 2005 to that in 2006?
Your answer should be very brief. 1.07. What is the ratio of the Cost of communications, computer etc. (% of service imports) in Sub-Saharan Africa (all income levels) in 2005 to that in 2007?
Make the answer very short. 0.96. What is the ratio of the Cost of communications, computer etc. (% of service imports) of Greece in 2005 to that in 2007?
Keep it short and to the point. 0.95. What is the ratio of the Cost of communications, computer etc. (% of service imports) in St. Lucia in 2005 to that in 2007?
Your response must be concise. 0.89. What is the ratio of the Cost of communications, computer etc. (% of service imports) in Sub-Saharan Africa (all income levels) in 2005 to that in 2008?
Offer a terse response. 1.01. What is the ratio of the Cost of communications, computer etc. (% of service imports) in Greece in 2005 to that in 2008?
Keep it short and to the point. 0.95. What is the ratio of the Cost of communications, computer etc. (% of service imports) in St. Lucia in 2005 to that in 2008?
Your answer should be compact. 1.04. What is the ratio of the Cost of communications, computer etc. (% of service imports) in Sub-Saharan Africa (all income levels) in 2005 to that in 2009?
Your response must be concise. 0.9. What is the ratio of the Cost of communications, computer etc. (% of service imports) of Greece in 2005 to that in 2009?
Your answer should be very brief. 0.84. What is the ratio of the Cost of communications, computer etc. (% of service imports) in Sub-Saharan Africa (all income levels) in 2005 to that in 2010?
Your response must be concise. 0.95. What is the ratio of the Cost of communications, computer etc. (% of service imports) in Greece in 2005 to that in 2010?
Offer a terse response. 0.94. What is the ratio of the Cost of communications, computer etc. (% of service imports) in St. Lucia in 2005 to that in 2010?
Offer a very short reply. 1.03. What is the ratio of the Cost of communications, computer etc. (% of service imports) in Sub-Saharan Africa (all income levels) in 2005 to that in 2011?
Make the answer very short. 0.88. What is the ratio of the Cost of communications, computer etc. (% of service imports) in Greece in 2005 to that in 2011?
Make the answer very short. 0.97. What is the ratio of the Cost of communications, computer etc. (% of service imports) in St. Lucia in 2005 to that in 2011?
Your response must be concise. 1.18. What is the ratio of the Cost of communications, computer etc. (% of service imports) in Sub-Saharan Africa (all income levels) in 2005 to that in 2012?
Offer a very short reply. 0.92. What is the ratio of the Cost of communications, computer etc. (% of service imports) in Greece in 2005 to that in 2012?
Make the answer very short. 1.03. What is the ratio of the Cost of communications, computer etc. (% of service imports) of St. Lucia in 2005 to that in 2012?
Your answer should be compact. 1.05. What is the ratio of the Cost of communications, computer etc. (% of service imports) of Sub-Saharan Africa (all income levels) in 2006 to that in 2007?
Provide a short and direct response. 0.98. What is the ratio of the Cost of communications, computer etc. (% of service imports) in St. Lucia in 2006 to that in 2007?
Your answer should be compact. 0.83. What is the ratio of the Cost of communications, computer etc. (% of service imports) in Sub-Saharan Africa (all income levels) in 2006 to that in 2008?
Offer a terse response. 1.04. What is the ratio of the Cost of communications, computer etc. (% of service imports) in St. Lucia in 2006 to that in 2008?
Your response must be concise. 0.97. What is the ratio of the Cost of communications, computer etc. (% of service imports) of Sub-Saharan Africa (all income levels) in 2006 to that in 2009?
Offer a very short reply. 0.93. What is the ratio of the Cost of communications, computer etc. (% of service imports) of Greece in 2006 to that in 2009?
Make the answer very short. 0.88. What is the ratio of the Cost of communications, computer etc. (% of service imports) in St. Lucia in 2006 to that in 2009?
Provide a succinct answer. 0.92. What is the ratio of the Cost of communications, computer etc. (% of service imports) in Sub-Saharan Africa (all income levels) in 2006 to that in 2010?
Provide a short and direct response. 0.97. What is the ratio of the Cost of communications, computer etc. (% of service imports) of Greece in 2006 to that in 2010?
Your answer should be compact. 0.98. What is the ratio of the Cost of communications, computer etc. (% of service imports) of St. Lucia in 2006 to that in 2010?
Provide a succinct answer. 0.96. What is the ratio of the Cost of communications, computer etc. (% of service imports) in Sub-Saharan Africa (all income levels) in 2006 to that in 2011?
Ensure brevity in your answer.  0.91. What is the ratio of the Cost of communications, computer etc. (% of service imports) of Greece in 2006 to that in 2011?
Provide a succinct answer. 1.02. What is the ratio of the Cost of communications, computer etc. (% of service imports) of St. Lucia in 2006 to that in 2011?
Your response must be concise. 1.1. What is the ratio of the Cost of communications, computer etc. (% of service imports) of Sub-Saharan Africa (all income levels) in 2006 to that in 2012?
Give a very brief answer. 0.94. What is the ratio of the Cost of communications, computer etc. (% of service imports) of Greece in 2006 to that in 2012?
Offer a very short reply. 1.08. What is the ratio of the Cost of communications, computer etc. (% of service imports) of St. Lucia in 2006 to that in 2012?
Provide a short and direct response. 0.98. What is the ratio of the Cost of communications, computer etc. (% of service imports) of Sub-Saharan Africa (all income levels) in 2007 to that in 2008?
Provide a short and direct response. 1.06. What is the ratio of the Cost of communications, computer etc. (% of service imports) of Greece in 2007 to that in 2008?
Offer a terse response. 1. What is the ratio of the Cost of communications, computer etc. (% of service imports) in St. Lucia in 2007 to that in 2008?
Give a very brief answer. 1.17. What is the ratio of the Cost of communications, computer etc. (% of service imports) of Sub-Saharan Africa (all income levels) in 2007 to that in 2009?
Your answer should be compact. 0.94. What is the ratio of the Cost of communications, computer etc. (% of service imports) of Greece in 2007 to that in 2009?
Your answer should be compact. 0.88. What is the ratio of the Cost of communications, computer etc. (% of service imports) of St. Lucia in 2007 to that in 2009?
Offer a terse response. 1.11. What is the ratio of the Cost of communications, computer etc. (% of service imports) in Sub-Saharan Africa (all income levels) in 2007 to that in 2010?
Keep it short and to the point. 0.99. What is the ratio of the Cost of communications, computer etc. (% of service imports) in Greece in 2007 to that in 2010?
Offer a terse response. 0.99. What is the ratio of the Cost of communications, computer etc. (% of service imports) of St. Lucia in 2007 to that in 2010?
Your response must be concise. 1.16. What is the ratio of the Cost of communications, computer etc. (% of service imports) in Sub-Saharan Africa (all income levels) in 2007 to that in 2011?
Provide a short and direct response. 0.92. What is the ratio of the Cost of communications, computer etc. (% of service imports) in Greece in 2007 to that in 2011?
Your answer should be compact. 1.03. What is the ratio of the Cost of communications, computer etc. (% of service imports) in St. Lucia in 2007 to that in 2011?
Your answer should be compact. 1.32. What is the ratio of the Cost of communications, computer etc. (% of service imports) of Sub-Saharan Africa (all income levels) in 2007 to that in 2012?
Your response must be concise. 0.96. What is the ratio of the Cost of communications, computer etc. (% of service imports) in Greece in 2007 to that in 2012?
Give a very brief answer. 1.08. What is the ratio of the Cost of communications, computer etc. (% of service imports) in St. Lucia in 2007 to that in 2012?
Your answer should be very brief. 1.19. What is the ratio of the Cost of communications, computer etc. (% of service imports) in Sub-Saharan Africa (all income levels) in 2008 to that in 2009?
Offer a very short reply. 0.89. What is the ratio of the Cost of communications, computer etc. (% of service imports) of Greece in 2008 to that in 2009?
Keep it short and to the point. 0.88. What is the ratio of the Cost of communications, computer etc. (% of service imports) in St. Lucia in 2008 to that in 2009?
Your answer should be very brief. 0.95. What is the ratio of the Cost of communications, computer etc. (% of service imports) of Sub-Saharan Africa (all income levels) in 2008 to that in 2010?
Keep it short and to the point. 0.94. What is the ratio of the Cost of communications, computer etc. (% of service imports) in Greece in 2008 to that in 2010?
Your response must be concise. 0.99. What is the ratio of the Cost of communications, computer etc. (% of service imports) in St. Lucia in 2008 to that in 2010?
Your response must be concise. 0.98. What is the ratio of the Cost of communications, computer etc. (% of service imports) of Sub-Saharan Africa (all income levels) in 2008 to that in 2011?
Give a very brief answer. 0.87. What is the ratio of the Cost of communications, computer etc. (% of service imports) of Greece in 2008 to that in 2011?
Give a very brief answer. 1.02. What is the ratio of the Cost of communications, computer etc. (% of service imports) in St. Lucia in 2008 to that in 2011?
Ensure brevity in your answer.  1.13. What is the ratio of the Cost of communications, computer etc. (% of service imports) of Sub-Saharan Africa (all income levels) in 2008 to that in 2012?
Provide a short and direct response. 0.9. What is the ratio of the Cost of communications, computer etc. (% of service imports) of Greece in 2008 to that in 2012?
Provide a succinct answer. 1.08. What is the ratio of the Cost of communications, computer etc. (% of service imports) in St. Lucia in 2008 to that in 2012?
Your response must be concise. 1.01. What is the ratio of the Cost of communications, computer etc. (% of service imports) of Sub-Saharan Africa (all income levels) in 2009 to that in 2010?
Keep it short and to the point. 1.05. What is the ratio of the Cost of communications, computer etc. (% of service imports) of Greece in 2009 to that in 2010?
Your answer should be compact. 1.12. What is the ratio of the Cost of communications, computer etc. (% of service imports) in St. Lucia in 2009 to that in 2010?
Make the answer very short. 1.04. What is the ratio of the Cost of communications, computer etc. (% of service imports) in Sub-Saharan Africa (all income levels) in 2009 to that in 2011?
Offer a very short reply. 0.98. What is the ratio of the Cost of communications, computer etc. (% of service imports) in Greece in 2009 to that in 2011?
Your answer should be very brief. 1.17. What is the ratio of the Cost of communications, computer etc. (% of service imports) in St. Lucia in 2009 to that in 2011?
Your response must be concise. 1.19. What is the ratio of the Cost of communications, computer etc. (% of service imports) in Sub-Saharan Africa (all income levels) in 2009 to that in 2012?
Provide a short and direct response. 1.01. What is the ratio of the Cost of communications, computer etc. (% of service imports) of Greece in 2009 to that in 2012?
Offer a very short reply. 1.23. What is the ratio of the Cost of communications, computer etc. (% of service imports) of St. Lucia in 2009 to that in 2012?
Ensure brevity in your answer.  1.07. What is the ratio of the Cost of communications, computer etc. (% of service imports) in Sub-Saharan Africa (all income levels) in 2010 to that in 2011?
Your response must be concise. 0.93. What is the ratio of the Cost of communications, computer etc. (% of service imports) of Greece in 2010 to that in 2011?
Your answer should be compact. 1.04. What is the ratio of the Cost of communications, computer etc. (% of service imports) in St. Lucia in 2010 to that in 2011?
Offer a very short reply. 1.15. What is the ratio of the Cost of communications, computer etc. (% of service imports) of Sub-Saharan Africa (all income levels) in 2010 to that in 2012?
Offer a very short reply. 0.97. What is the ratio of the Cost of communications, computer etc. (% of service imports) in Greece in 2010 to that in 2012?
Keep it short and to the point. 1.1. What is the ratio of the Cost of communications, computer etc. (% of service imports) in St. Lucia in 2010 to that in 2012?
Your answer should be compact. 1.03. What is the ratio of the Cost of communications, computer etc. (% of service imports) in Sub-Saharan Africa (all income levels) in 2011 to that in 2012?
Provide a short and direct response. 1.03. What is the ratio of the Cost of communications, computer etc. (% of service imports) in Greece in 2011 to that in 2012?
Offer a terse response. 1.06. What is the ratio of the Cost of communications, computer etc. (% of service imports) of St. Lucia in 2011 to that in 2012?
Offer a terse response. 0.9. What is the difference between the highest and the second highest Cost of communications, computer etc. (% of service imports) of Sub-Saharan Africa (all income levels)?
Keep it short and to the point. 0.94. What is the difference between the highest and the second highest Cost of communications, computer etc. (% of service imports) in Greece?
Provide a succinct answer. 2.87. What is the difference between the highest and the second highest Cost of communications, computer etc. (% of service imports) in St. Lucia?
Offer a very short reply. 3.31. What is the difference between the highest and the lowest Cost of communications, computer etc. (% of service imports) in Sub-Saharan Africa (all income levels)?
Give a very brief answer. 5.5. What is the difference between the highest and the lowest Cost of communications, computer etc. (% of service imports) of Greece?
Your response must be concise. 4.96. What is the difference between the highest and the lowest Cost of communications, computer etc. (% of service imports) in St. Lucia?
Offer a terse response. 7.97. 